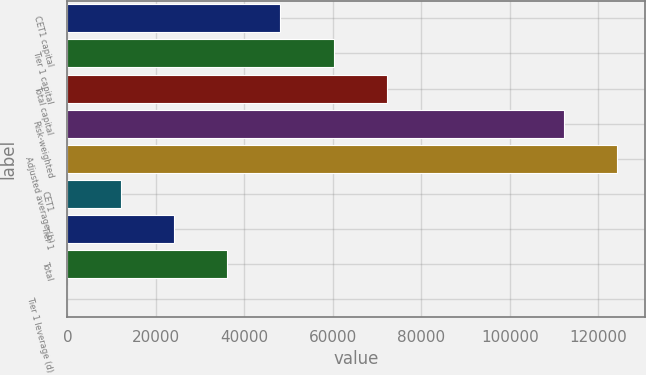Convert chart to OTSL. <chart><loc_0><loc_0><loc_500><loc_500><bar_chart><fcel>CET1 capital<fcel>Tier 1 capital<fcel>Total capital<fcel>Risk-weighted<fcel>Adjusted average (b)<fcel>CET1<fcel>Tier 1<fcel>Total<fcel>Tier 1 leverage (d)<nl><fcel>48130<fcel>60159<fcel>72188<fcel>112297<fcel>124326<fcel>12043<fcel>24072<fcel>36101<fcel>14<nl></chart> 